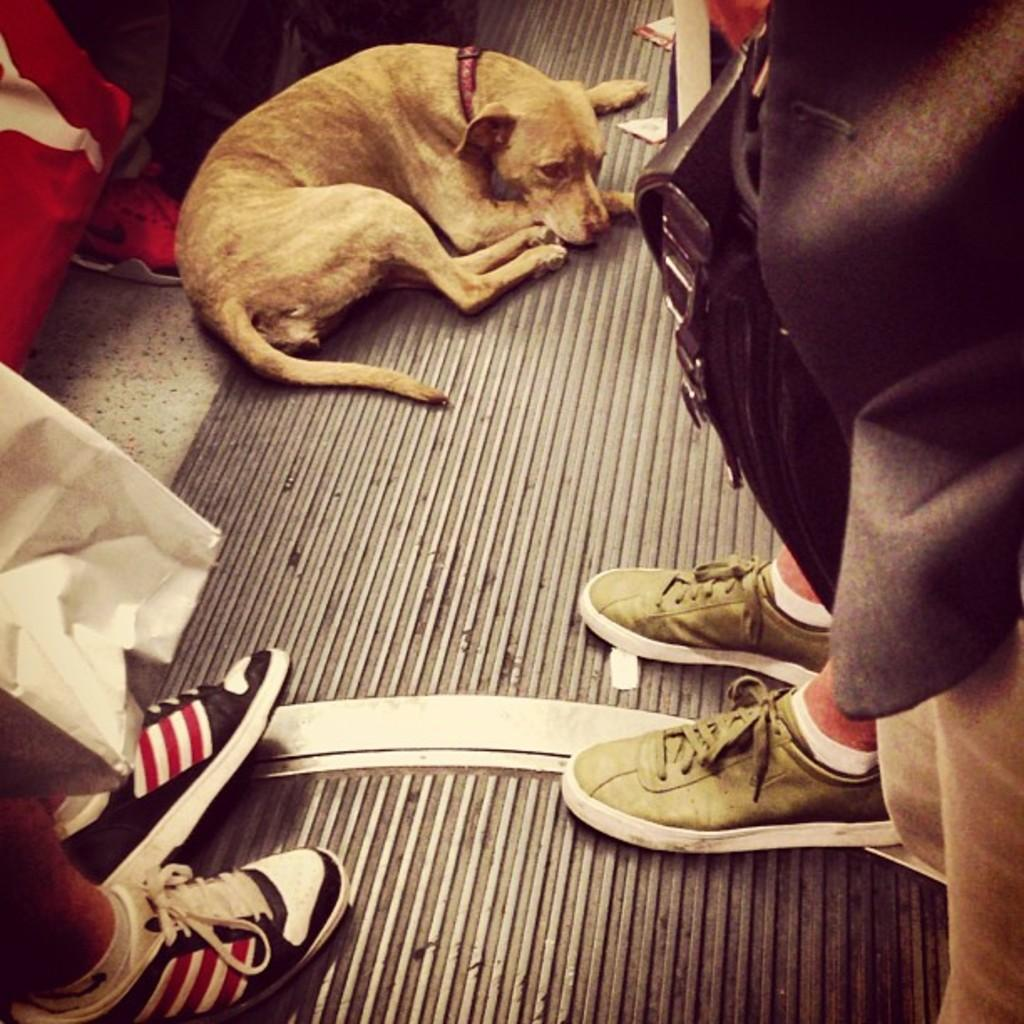What animal is lying on the floor in the image? There is a dog lying on the floor in the image. What are the people doing in relation to the dog in the image? The people are standing around the dog in the image. What objects are the people holding in the image? The people are holding bags in the image. What type of flag is being waved by the dog in the image? There is no flag present in the image, and the dog is not waving anything. 